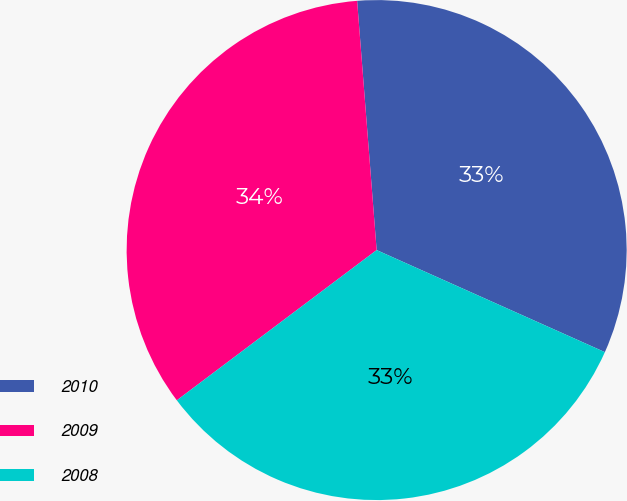<chart> <loc_0><loc_0><loc_500><loc_500><pie_chart><fcel>2010<fcel>2009<fcel>2008<nl><fcel>32.94%<fcel>34.02%<fcel>33.05%<nl></chart> 